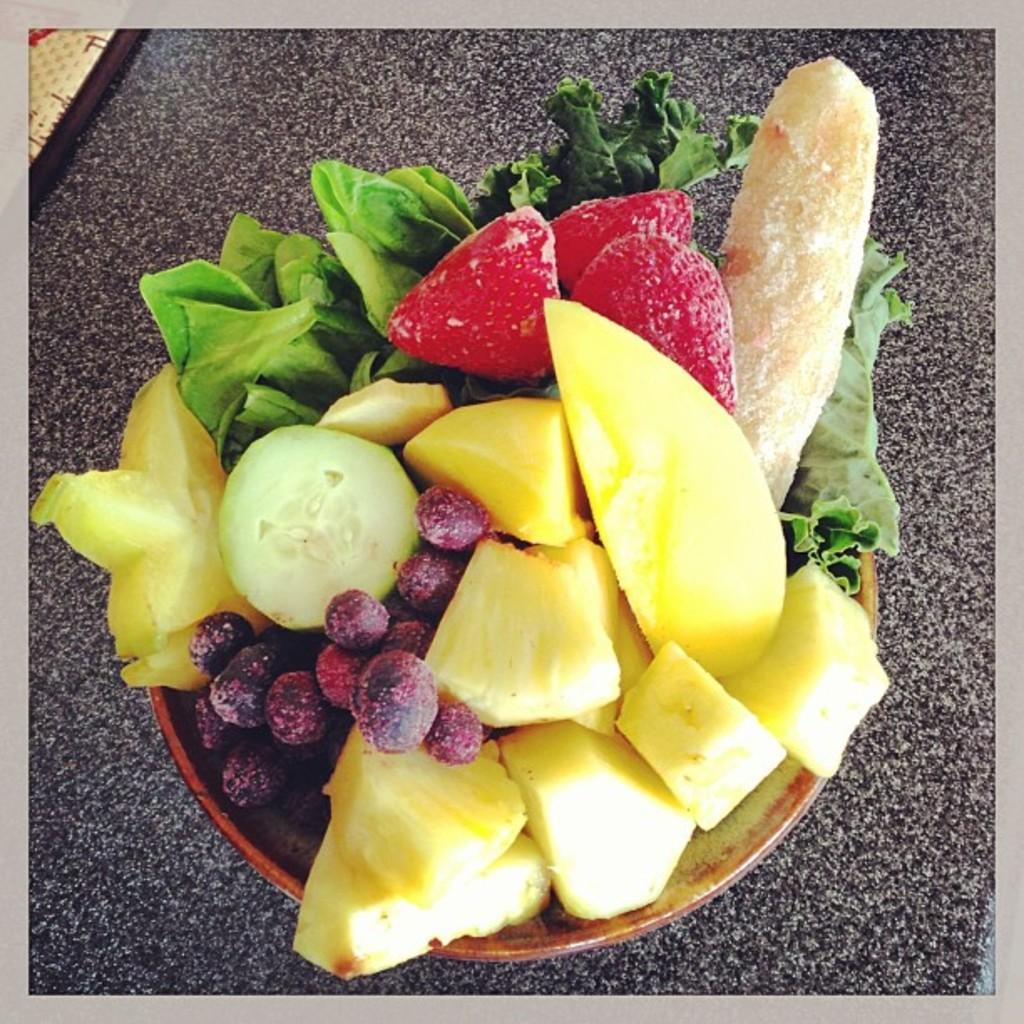In one or two sentences, can you explain what this image depicts? In this image, we can see a bowl contains cut fruits, grapes, strawberries and leafy vegetables. 